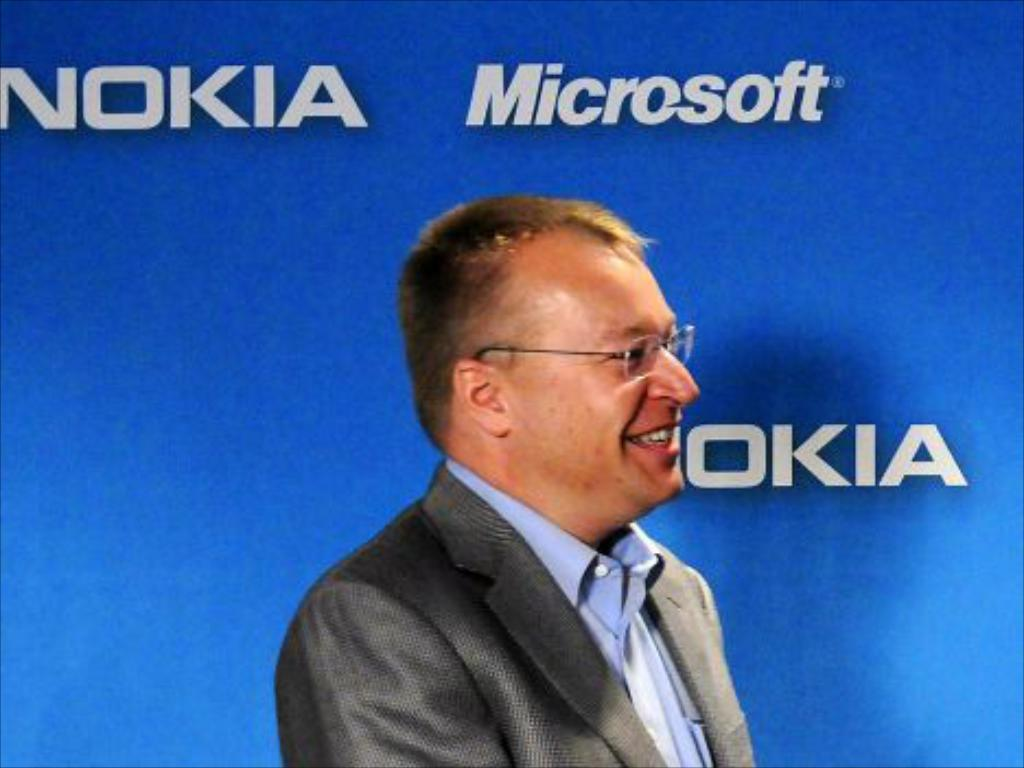Who is present in the image? There is a man in the image. What can be observed about the man's appearance? The man is wearing glasses and smiling. What is the color of the wall in the background of the image? There is a blue wall in the background of the image. Is there any text or writing visible in the image? Yes, there is writing on the blue wall. What type of tub is visible in the image? There is no tub present in the image. What grade did the man receive for his performance in the image? There is no indication of a grade or performance in the image. 